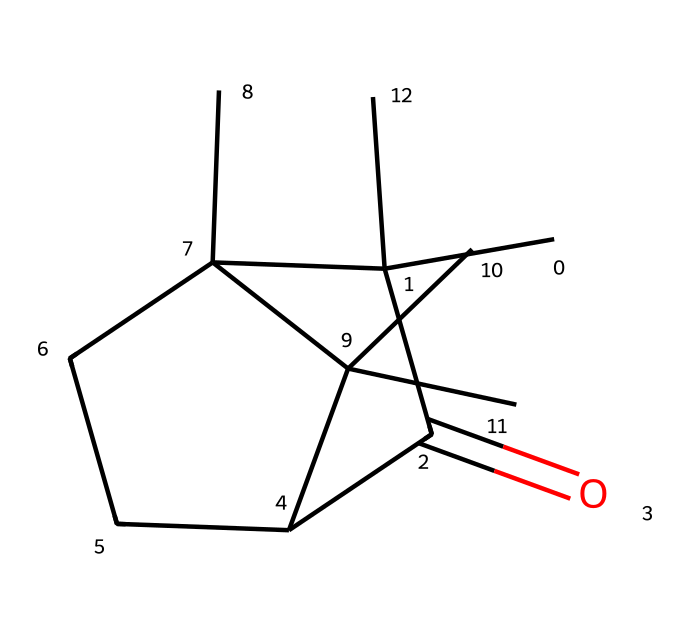How many carbon atoms are in camphor? By examining the SMILES representation, we can identify the number of carbon (C) symbols present. Counting carefully, there are 15 carbon atoms represented in the structure.
Answer: 15 What is the functional group present in camphor? Looking at the chemical structure, the main functional group is a ketone indicated by the C(=O) notation, which signifies a carbon atom double bonded to an oxygen atom.
Answer: ketone Is camphor a cyclic compound? The presence of a closed ring structure, as indicated by the numbers (1 and 2) in the SMILES notation, confirms that camphor is indeed a cyclic compound.
Answer: yes How many hydrogen atoms are there in camphor? From the SMILES representation, each carbon typically binds to hydrogen to fulfill its four-bond requirement, considering the existing double bond and other bonds in the structure. After accounting for this, there are 26 hydrogen atoms in total.
Answer: 26 What type of cycloalkane is camphor classified as? Camphor belongs to the class of bicyclic compounds due to its two interconnected ring systems, evident from the multiple ring closures in the structure.
Answer: bicyclic Does camphor have any chiral centers? By analyzing the carbon atoms in the structure, we can look for tetrahedral carbon atoms (four different substituents). In the case of camphor, there are two carbons that fit this criteria, indicating the presence of chiral centers.
Answer: yes What type of chemical reaction is commonly associated with camphor? Camphor often undergoes oxidation reactions due to the presence of its ketone functional group, which is characteristic of its reactivity.
Answer: oxidation 